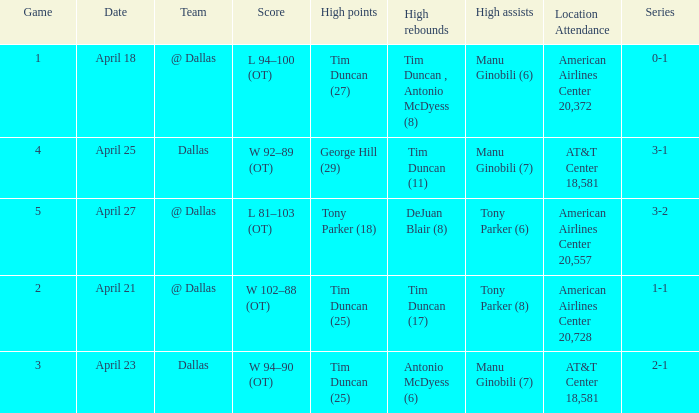When 5 is the game who has the highest amount of points? Tony Parker (18). 